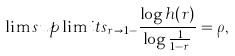<formula> <loc_0><loc_0><loc_500><loc_500>\lim s u p \lim i t s _ { r \rightarrow 1 - } \frac { \log h ( r ) } { \log \frac { 1 } { 1 - r } } = \rho ,</formula> 